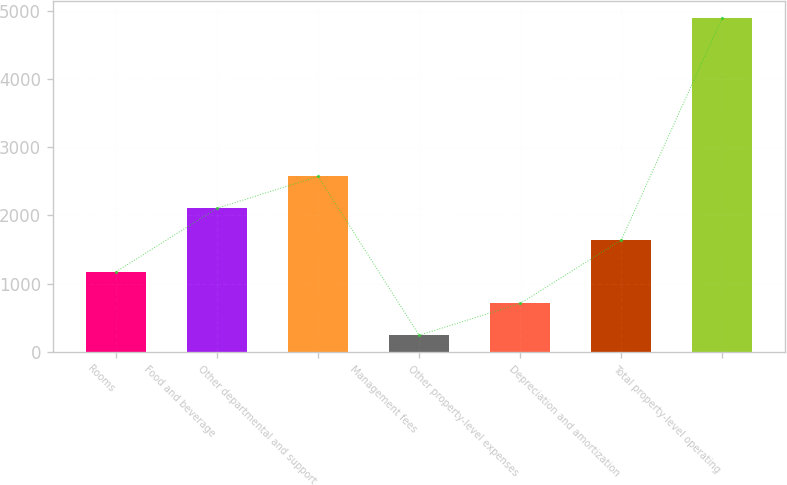Convert chart to OTSL. <chart><loc_0><loc_0><loc_500><loc_500><bar_chart><fcel>Rooms<fcel>Food and beverage<fcel>Other departmental and support<fcel>Management fees<fcel>Other property-level expenses<fcel>Depreciation and amortization<fcel>Total property-level operating<nl><fcel>1173.8<fcel>2104.6<fcel>2570<fcel>243<fcel>708.4<fcel>1639.2<fcel>4897<nl></chart> 